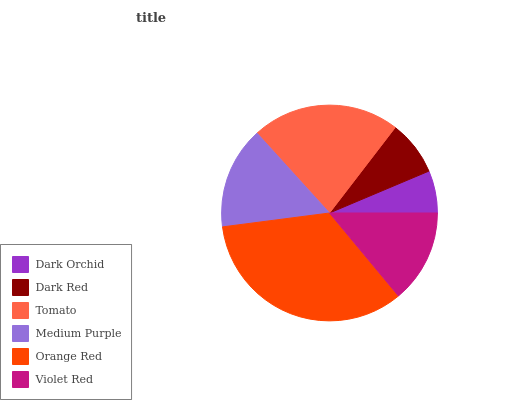Is Dark Orchid the minimum?
Answer yes or no. Yes. Is Orange Red the maximum?
Answer yes or no. Yes. Is Dark Red the minimum?
Answer yes or no. No. Is Dark Red the maximum?
Answer yes or no. No. Is Dark Red greater than Dark Orchid?
Answer yes or no. Yes. Is Dark Orchid less than Dark Red?
Answer yes or no. Yes. Is Dark Orchid greater than Dark Red?
Answer yes or no. No. Is Dark Red less than Dark Orchid?
Answer yes or no. No. Is Medium Purple the high median?
Answer yes or no. Yes. Is Violet Red the low median?
Answer yes or no. Yes. Is Dark Red the high median?
Answer yes or no. No. Is Dark Orchid the low median?
Answer yes or no. No. 